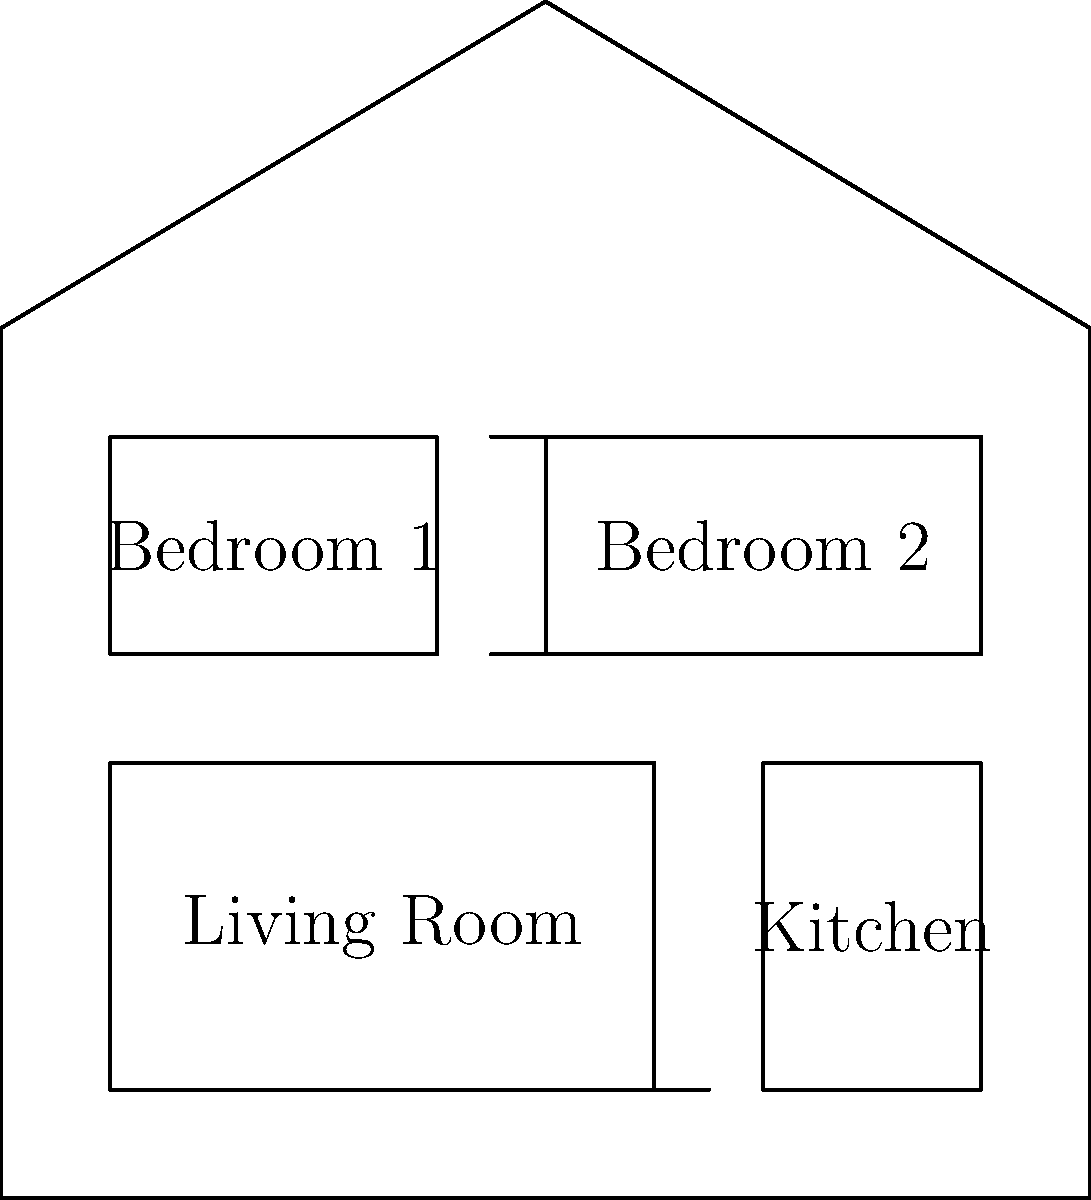In the children's book "The Cozy Cottage," the author describes a small house with a living room, kitchen, and two bedrooms. The living room is the largest room and is located on the left side of the house. The kitchen is smaller and positioned to the right of the living room. Two equal-sized bedrooms are upstairs, side by side. Based on this description, which of the following floor plans best represents the layout of the house in "The Cozy Cottage"? To answer this question, we need to analyze the given floor plan and compare it to the description in the book. Let's break it down step-by-step:

1. The house shape: The floor plan shows a simple house shape with a pitched roof, which is typical for a cozy cottage.

2. Room layout:
   a. Living Room: The largest room is on the left side of the house, as described.
   b. Kitchen: A smaller room is positioned to the right of the living room, matching the description.
   c. Bedrooms: Two equal-sized rooms are shown above the living room and kitchen, representing the upstairs bedrooms.

3. Room proportions:
   a. The living room is indeed the largest room in the house.
   b. The kitchen is smaller than the living room.
   c. The two bedrooms are of equal size and positioned side by side.

4. Door placement:
   a. There's a door between the living room and kitchen.
   b. Two doors are shown leading to the bedrooms, indicating separate entrances.

5. Overall layout:
   The floor plan effectively represents a two-story cottage with the described room arrangement. The lower floor contains the living areas, while the upper floor houses the bedrooms.

Given these observations, the provided floor plan accurately matches the description of "The Cozy Cottage" from the children's book. It includes all the mentioned rooms in the correct positions and proportions.
Answer: The given floor plan accurately represents "The Cozy Cottage." 